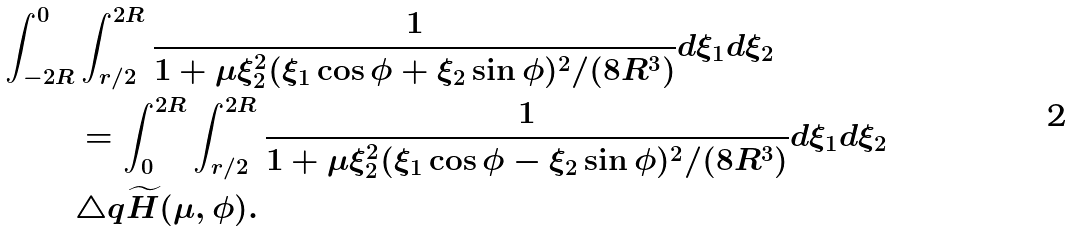Convert formula to latex. <formula><loc_0><loc_0><loc_500><loc_500>\int _ { - 2 R } ^ { 0 } & \int _ { r / 2 } ^ { 2 R } \frac { 1 } { 1 + \mu \xi _ { 2 } ^ { 2 } ( \xi _ { 1 } \cos \phi + \xi _ { 2 } \sin \phi ) ^ { 2 } / ( 8 R ^ { 3 } ) } d \xi _ { 1 } d \xi _ { 2 } \\ & = \int _ { 0 } ^ { 2 R } \int _ { r / 2 } ^ { 2 R } \frac { 1 } { 1 + \mu \xi _ { 2 } ^ { 2 } ( \xi _ { 1 } \cos \phi - \xi _ { 2 } \sin \phi ) ^ { 2 } / ( 8 R ^ { 3 } ) } d \xi _ { 1 } d \xi _ { 2 } \\ & \triangle q \widetilde { H } ( \mu , \phi ) .</formula> 